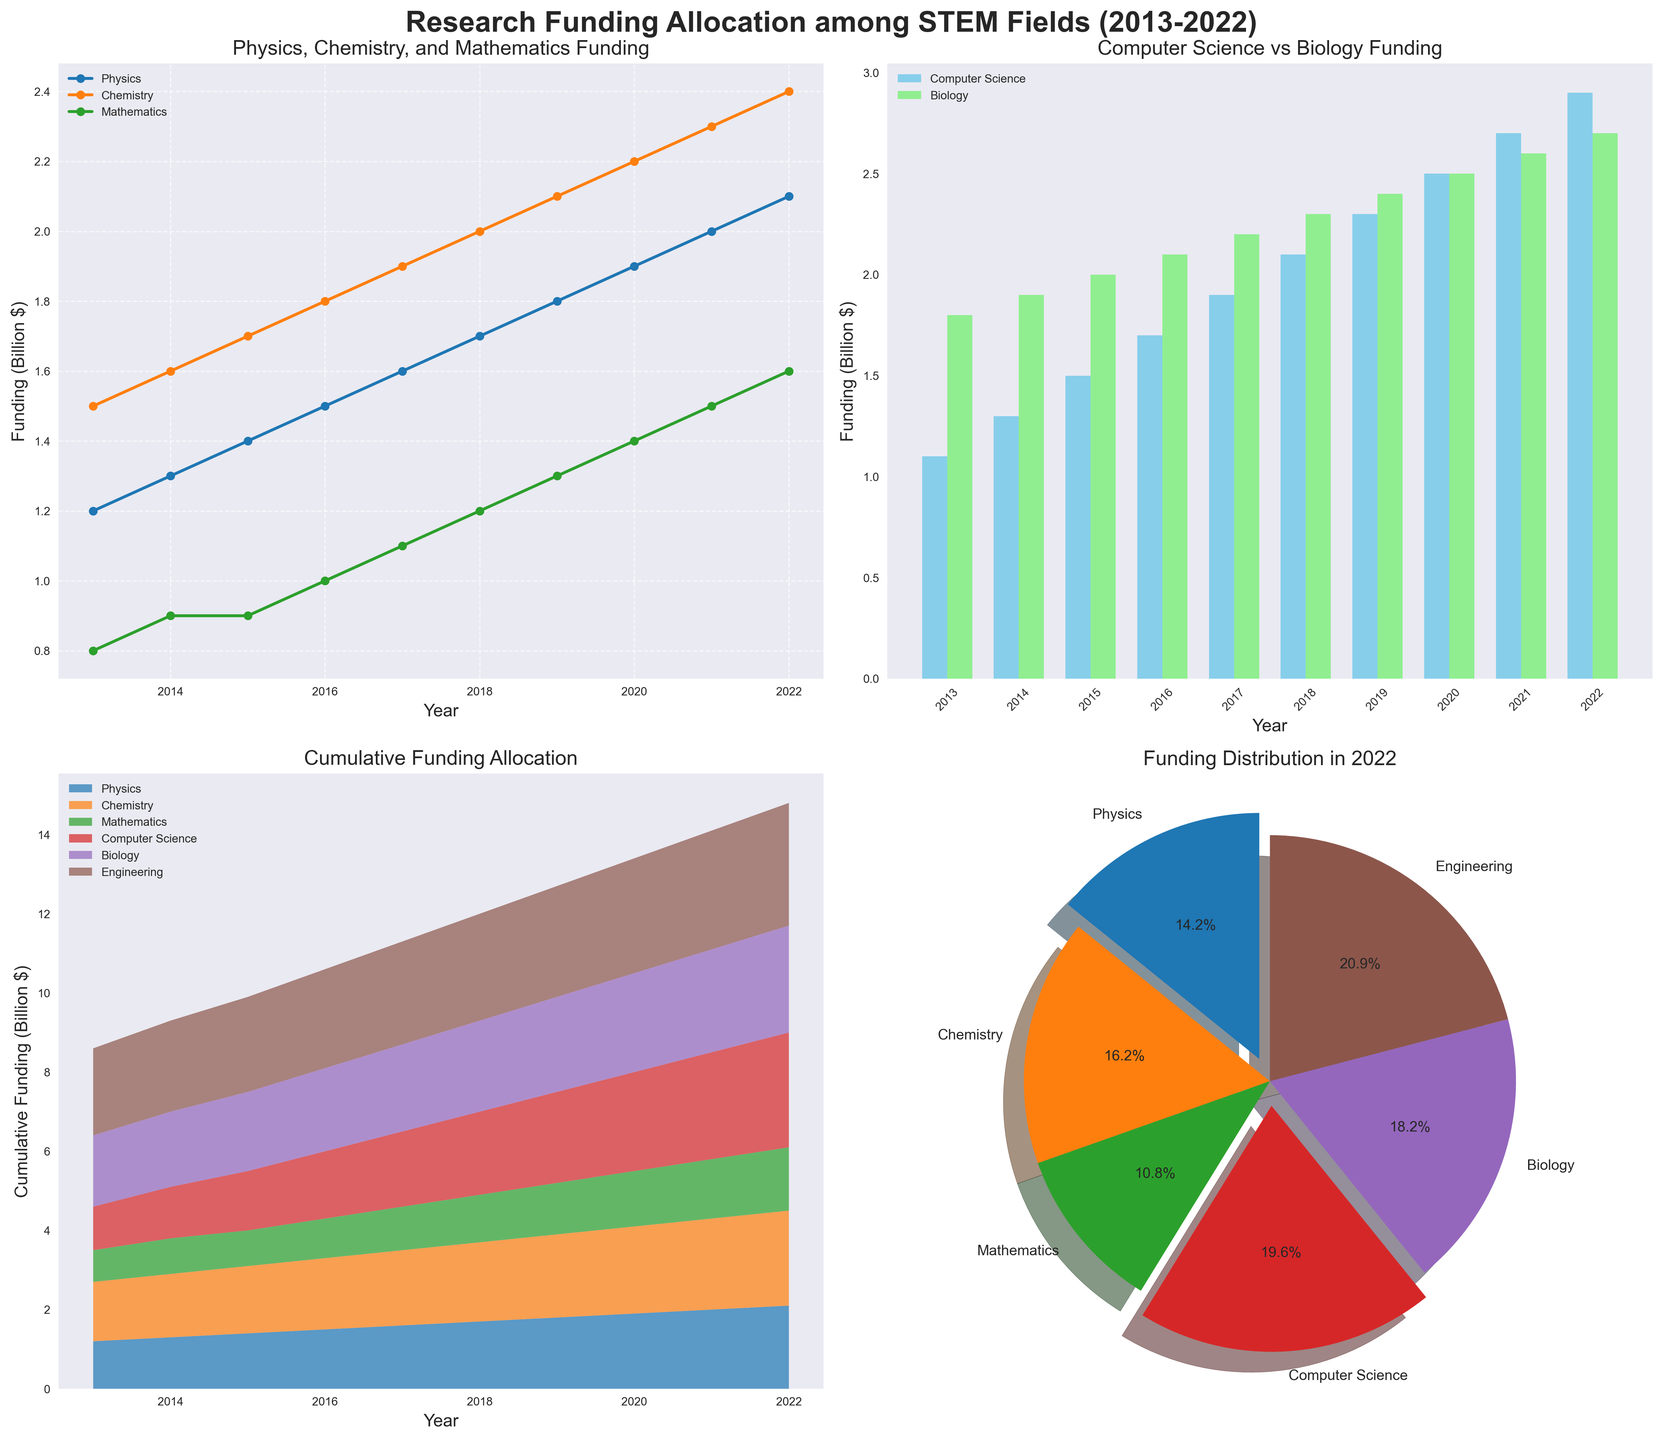What is the title of the entire figure? The title of the entire figure is usually found at the top center of the visualization. In the provided code, it's set using `fig.suptitle`.
Answer: Research Funding Allocation among STEM Fields (2013-2022) How is the funding trend for Mathematics displayed in the line plot subplot? The line plot subplot shows the funding trends for Physics, Chemistry, and Mathematics. The funding trend for Mathematics can be identified as the line that corresponds to it among the three and it is marked by the legend.
Answer: It is a slightly increasing trend from 0.8 to 1.6 billion dollars over the years How does the funding for Computer Science in 2018 compare with that of Biology in the same year? In the bar plot subplot, each year has two bars, one for Computer Science and one for Biology. By examining the heights of these bars for 2018, we can compare them.
Answer: Computer Science funding is 2.1 billion dollars, while Biology funding is 2.3 billion dollars Which field received the most funding overall in 2022 according to the pie chart? The field with the largest slice in the pie chart for 2022 will have received the most funding. This is visually identifiable by both the degree of the slice and the percentage label.
Answer: Engineering What is the combined funding for Physics, Chemistry, and Mathematics in 2016? To get the combined funding for these three fields in 2016, we need to add the individual funding numbers: 1.5 for Physics, 1.8 for Chemistry, and 1.0 for Mathematics.
Answer: 4.3 billion dollars In the cumulative funding allocation area plot, which year shows the most significant increase in total funding? The area plot visually represents cumulative funding over the years. The year with the steepest rise in the area graph shows the most significant increase.
Answer: 2022 Is the total funding for Biology ever higher than for Computer Science from 2013 to 2022? Comparing the individual funding lines year by year for Biology and Computer Science in the bar plot can help identify if there is any year where Biology's funding surpasses Computer Science's funding.
Answer: No How does the funding growth rate of Engineering compare to that of Physics over the decade? By comparing the steepness of the lines in the stacked area plot and the values in the line plot, we can infer the growth rate. Engineering's funding starts higher and grows steadily, while Physics starts lower but with a steeper rise.
Answer: Engineering's funding grows at a relatively steady rate, while Physics shows a rapid increase What percentage of the total funding in 2022 is allocated to Computer Science? The pie chart shows funding allocation percentages. To find Computer Science's percentage, locate its slice and read the label or calculate it from its slice size.
Answer: 19.7% How much did the funding for Chemistry increase from 2013 to 2022? To determine the increase, subtract the 2013 funding value for Chemistry from the 2022 value: 2.4 billion dollars in 2022 minus 1.5 billion dollars in 2013.
Answer: 0.9 billion dollars 